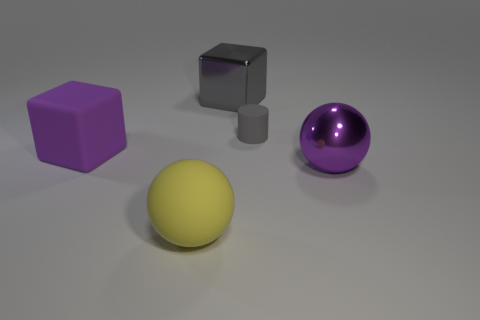Add 5 rubber cubes. How many objects exist? 10 Subtract all purple cubes. How many cubes are left? 1 Subtract 1 balls. How many balls are left? 1 Subtract all red blocks. How many yellow spheres are left? 1 Subtract all big yellow rubber balls. Subtract all small cylinders. How many objects are left? 3 Add 3 big matte things. How many big matte things are left? 5 Add 2 red rubber things. How many red rubber things exist? 2 Subtract 0 red spheres. How many objects are left? 5 Subtract all cylinders. How many objects are left? 4 Subtract all cyan spheres. Subtract all green cylinders. How many spheres are left? 2 